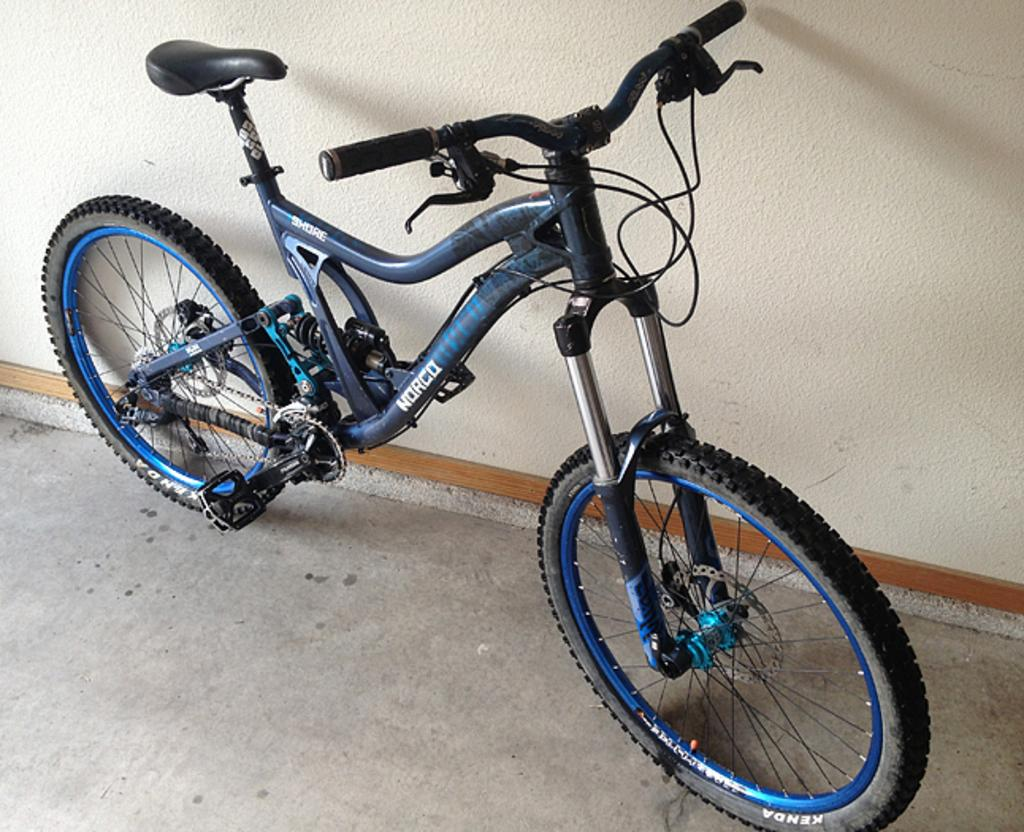What is the main object in the image? There is a bicycle in the image. How is the bicycle positioned in the image? The bicycle is parked on the floor. What can be seen behind the bicycle? There is a wall visible behind the bicycle. What type of detail can be seen on the wall behind the bicycle? There is no specific detail mentioned on the wall behind the bicycle in the image. 